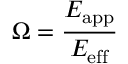<formula> <loc_0><loc_0><loc_500><loc_500>\Omega = \frac { E _ { a p p } } { E _ { e f f } }</formula> 